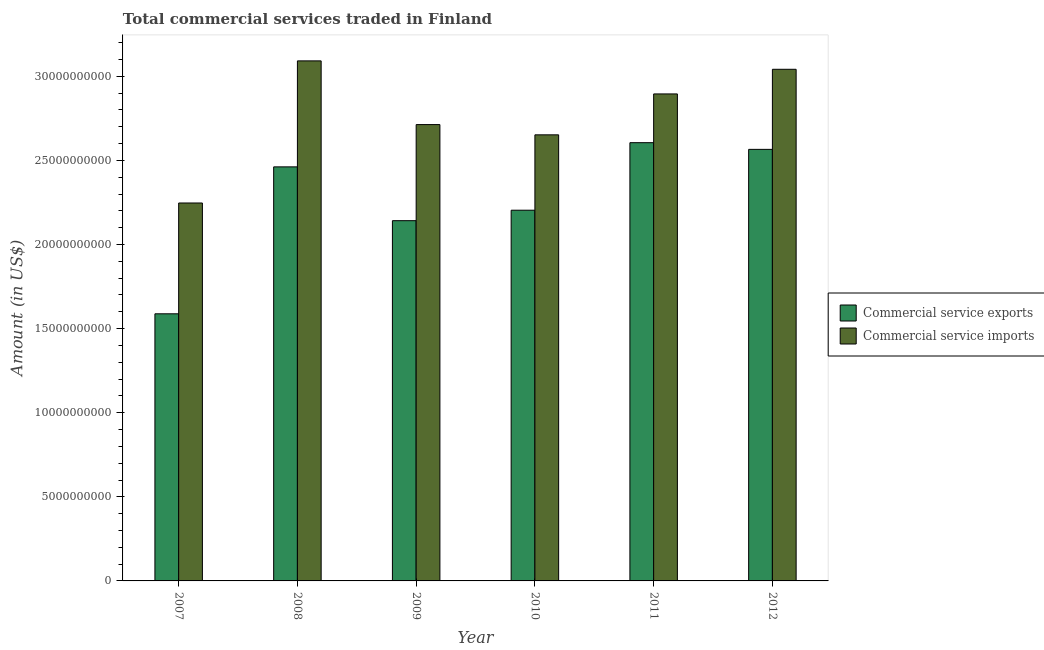How many bars are there on the 1st tick from the left?
Make the answer very short. 2. What is the label of the 4th group of bars from the left?
Provide a short and direct response. 2010. In how many cases, is the number of bars for a given year not equal to the number of legend labels?
Offer a very short reply. 0. What is the amount of commercial service exports in 2008?
Your answer should be compact. 2.46e+1. Across all years, what is the maximum amount of commercial service imports?
Offer a very short reply. 3.09e+1. Across all years, what is the minimum amount of commercial service exports?
Keep it short and to the point. 1.59e+1. In which year was the amount of commercial service imports maximum?
Your answer should be very brief. 2008. What is the total amount of commercial service imports in the graph?
Offer a very short reply. 1.66e+11. What is the difference between the amount of commercial service imports in 2008 and that in 2011?
Your answer should be very brief. 1.96e+09. What is the difference between the amount of commercial service imports in 2012 and the amount of commercial service exports in 2007?
Make the answer very short. 7.95e+09. What is the average amount of commercial service imports per year?
Keep it short and to the point. 2.77e+1. In how many years, is the amount of commercial service exports greater than 15000000000 US$?
Ensure brevity in your answer.  6. What is the ratio of the amount of commercial service exports in 2010 to that in 2012?
Give a very brief answer. 0.86. What is the difference between the highest and the second highest amount of commercial service imports?
Make the answer very short. 5.00e+08. What is the difference between the highest and the lowest amount of commercial service imports?
Offer a very short reply. 8.45e+09. Is the sum of the amount of commercial service imports in 2007 and 2012 greater than the maximum amount of commercial service exports across all years?
Offer a terse response. Yes. What does the 2nd bar from the left in 2007 represents?
Provide a short and direct response. Commercial service imports. What does the 2nd bar from the right in 2007 represents?
Ensure brevity in your answer.  Commercial service exports. Are all the bars in the graph horizontal?
Offer a very short reply. No. How many years are there in the graph?
Your answer should be very brief. 6. What is the difference between two consecutive major ticks on the Y-axis?
Offer a very short reply. 5.00e+09. What is the title of the graph?
Your answer should be compact. Total commercial services traded in Finland. What is the Amount (in US$) in Commercial service exports in 2007?
Provide a succinct answer. 1.59e+1. What is the Amount (in US$) of Commercial service imports in 2007?
Your response must be concise. 2.25e+1. What is the Amount (in US$) in Commercial service exports in 2008?
Your answer should be compact. 2.46e+1. What is the Amount (in US$) in Commercial service imports in 2008?
Your answer should be very brief. 3.09e+1. What is the Amount (in US$) in Commercial service exports in 2009?
Make the answer very short. 2.14e+1. What is the Amount (in US$) in Commercial service imports in 2009?
Give a very brief answer. 2.71e+1. What is the Amount (in US$) in Commercial service exports in 2010?
Your answer should be very brief. 2.20e+1. What is the Amount (in US$) in Commercial service imports in 2010?
Provide a succinct answer. 2.65e+1. What is the Amount (in US$) of Commercial service exports in 2011?
Keep it short and to the point. 2.61e+1. What is the Amount (in US$) of Commercial service imports in 2011?
Your response must be concise. 2.90e+1. What is the Amount (in US$) in Commercial service exports in 2012?
Provide a succinct answer. 2.57e+1. What is the Amount (in US$) of Commercial service imports in 2012?
Ensure brevity in your answer.  3.04e+1. Across all years, what is the maximum Amount (in US$) of Commercial service exports?
Keep it short and to the point. 2.61e+1. Across all years, what is the maximum Amount (in US$) in Commercial service imports?
Offer a very short reply. 3.09e+1. Across all years, what is the minimum Amount (in US$) in Commercial service exports?
Offer a very short reply. 1.59e+1. Across all years, what is the minimum Amount (in US$) of Commercial service imports?
Offer a terse response. 2.25e+1. What is the total Amount (in US$) of Commercial service exports in the graph?
Provide a succinct answer. 1.36e+11. What is the total Amount (in US$) in Commercial service imports in the graph?
Offer a terse response. 1.66e+11. What is the difference between the Amount (in US$) of Commercial service exports in 2007 and that in 2008?
Your answer should be compact. -8.74e+09. What is the difference between the Amount (in US$) in Commercial service imports in 2007 and that in 2008?
Make the answer very short. -8.45e+09. What is the difference between the Amount (in US$) of Commercial service exports in 2007 and that in 2009?
Make the answer very short. -5.54e+09. What is the difference between the Amount (in US$) of Commercial service imports in 2007 and that in 2009?
Your answer should be very brief. -4.66e+09. What is the difference between the Amount (in US$) in Commercial service exports in 2007 and that in 2010?
Give a very brief answer. -6.16e+09. What is the difference between the Amount (in US$) in Commercial service imports in 2007 and that in 2010?
Your answer should be compact. -4.05e+09. What is the difference between the Amount (in US$) in Commercial service exports in 2007 and that in 2011?
Provide a succinct answer. -1.02e+1. What is the difference between the Amount (in US$) in Commercial service imports in 2007 and that in 2011?
Your response must be concise. -6.48e+09. What is the difference between the Amount (in US$) in Commercial service exports in 2007 and that in 2012?
Offer a terse response. -9.78e+09. What is the difference between the Amount (in US$) in Commercial service imports in 2007 and that in 2012?
Ensure brevity in your answer.  -7.95e+09. What is the difference between the Amount (in US$) in Commercial service exports in 2008 and that in 2009?
Provide a short and direct response. 3.20e+09. What is the difference between the Amount (in US$) in Commercial service imports in 2008 and that in 2009?
Make the answer very short. 3.79e+09. What is the difference between the Amount (in US$) in Commercial service exports in 2008 and that in 2010?
Give a very brief answer. 2.58e+09. What is the difference between the Amount (in US$) in Commercial service imports in 2008 and that in 2010?
Ensure brevity in your answer.  4.40e+09. What is the difference between the Amount (in US$) in Commercial service exports in 2008 and that in 2011?
Offer a terse response. -1.44e+09. What is the difference between the Amount (in US$) in Commercial service imports in 2008 and that in 2011?
Provide a succinct answer. 1.96e+09. What is the difference between the Amount (in US$) of Commercial service exports in 2008 and that in 2012?
Keep it short and to the point. -1.04e+09. What is the difference between the Amount (in US$) in Commercial service imports in 2008 and that in 2012?
Your answer should be compact. 5.00e+08. What is the difference between the Amount (in US$) in Commercial service exports in 2009 and that in 2010?
Offer a very short reply. -6.22e+08. What is the difference between the Amount (in US$) in Commercial service imports in 2009 and that in 2010?
Provide a short and direct response. 6.09e+08. What is the difference between the Amount (in US$) of Commercial service exports in 2009 and that in 2011?
Give a very brief answer. -4.64e+09. What is the difference between the Amount (in US$) of Commercial service imports in 2009 and that in 2011?
Your answer should be very brief. -1.82e+09. What is the difference between the Amount (in US$) in Commercial service exports in 2009 and that in 2012?
Make the answer very short. -4.24e+09. What is the difference between the Amount (in US$) in Commercial service imports in 2009 and that in 2012?
Your response must be concise. -3.29e+09. What is the difference between the Amount (in US$) in Commercial service exports in 2010 and that in 2011?
Your answer should be very brief. -4.02e+09. What is the difference between the Amount (in US$) in Commercial service imports in 2010 and that in 2011?
Make the answer very short. -2.43e+09. What is the difference between the Amount (in US$) in Commercial service exports in 2010 and that in 2012?
Your response must be concise. -3.62e+09. What is the difference between the Amount (in US$) of Commercial service imports in 2010 and that in 2012?
Provide a short and direct response. -3.90e+09. What is the difference between the Amount (in US$) of Commercial service exports in 2011 and that in 2012?
Your answer should be compact. 3.98e+08. What is the difference between the Amount (in US$) of Commercial service imports in 2011 and that in 2012?
Your answer should be very brief. -1.46e+09. What is the difference between the Amount (in US$) in Commercial service exports in 2007 and the Amount (in US$) in Commercial service imports in 2008?
Give a very brief answer. -1.50e+1. What is the difference between the Amount (in US$) in Commercial service exports in 2007 and the Amount (in US$) in Commercial service imports in 2009?
Your answer should be very brief. -1.13e+1. What is the difference between the Amount (in US$) of Commercial service exports in 2007 and the Amount (in US$) of Commercial service imports in 2010?
Provide a short and direct response. -1.06e+1. What is the difference between the Amount (in US$) in Commercial service exports in 2007 and the Amount (in US$) in Commercial service imports in 2011?
Keep it short and to the point. -1.31e+1. What is the difference between the Amount (in US$) in Commercial service exports in 2007 and the Amount (in US$) in Commercial service imports in 2012?
Your answer should be very brief. -1.45e+1. What is the difference between the Amount (in US$) in Commercial service exports in 2008 and the Amount (in US$) in Commercial service imports in 2009?
Give a very brief answer. -2.51e+09. What is the difference between the Amount (in US$) of Commercial service exports in 2008 and the Amount (in US$) of Commercial service imports in 2010?
Make the answer very short. -1.90e+09. What is the difference between the Amount (in US$) of Commercial service exports in 2008 and the Amount (in US$) of Commercial service imports in 2011?
Provide a succinct answer. -4.34e+09. What is the difference between the Amount (in US$) of Commercial service exports in 2008 and the Amount (in US$) of Commercial service imports in 2012?
Ensure brevity in your answer.  -5.80e+09. What is the difference between the Amount (in US$) of Commercial service exports in 2009 and the Amount (in US$) of Commercial service imports in 2010?
Offer a terse response. -5.10e+09. What is the difference between the Amount (in US$) of Commercial service exports in 2009 and the Amount (in US$) of Commercial service imports in 2011?
Your answer should be very brief. -7.54e+09. What is the difference between the Amount (in US$) in Commercial service exports in 2009 and the Amount (in US$) in Commercial service imports in 2012?
Offer a very short reply. -9.00e+09. What is the difference between the Amount (in US$) in Commercial service exports in 2010 and the Amount (in US$) in Commercial service imports in 2011?
Make the answer very short. -6.91e+09. What is the difference between the Amount (in US$) of Commercial service exports in 2010 and the Amount (in US$) of Commercial service imports in 2012?
Keep it short and to the point. -8.38e+09. What is the difference between the Amount (in US$) of Commercial service exports in 2011 and the Amount (in US$) of Commercial service imports in 2012?
Keep it short and to the point. -4.36e+09. What is the average Amount (in US$) in Commercial service exports per year?
Your response must be concise. 2.26e+1. What is the average Amount (in US$) of Commercial service imports per year?
Make the answer very short. 2.77e+1. In the year 2007, what is the difference between the Amount (in US$) in Commercial service exports and Amount (in US$) in Commercial service imports?
Make the answer very short. -6.59e+09. In the year 2008, what is the difference between the Amount (in US$) of Commercial service exports and Amount (in US$) of Commercial service imports?
Provide a short and direct response. -6.30e+09. In the year 2009, what is the difference between the Amount (in US$) of Commercial service exports and Amount (in US$) of Commercial service imports?
Give a very brief answer. -5.71e+09. In the year 2010, what is the difference between the Amount (in US$) in Commercial service exports and Amount (in US$) in Commercial service imports?
Ensure brevity in your answer.  -4.48e+09. In the year 2011, what is the difference between the Amount (in US$) in Commercial service exports and Amount (in US$) in Commercial service imports?
Make the answer very short. -2.90e+09. In the year 2012, what is the difference between the Amount (in US$) of Commercial service exports and Amount (in US$) of Commercial service imports?
Provide a succinct answer. -4.76e+09. What is the ratio of the Amount (in US$) of Commercial service exports in 2007 to that in 2008?
Your response must be concise. 0.65. What is the ratio of the Amount (in US$) in Commercial service imports in 2007 to that in 2008?
Ensure brevity in your answer.  0.73. What is the ratio of the Amount (in US$) in Commercial service exports in 2007 to that in 2009?
Your answer should be very brief. 0.74. What is the ratio of the Amount (in US$) in Commercial service imports in 2007 to that in 2009?
Your answer should be compact. 0.83. What is the ratio of the Amount (in US$) in Commercial service exports in 2007 to that in 2010?
Offer a terse response. 0.72. What is the ratio of the Amount (in US$) in Commercial service imports in 2007 to that in 2010?
Your response must be concise. 0.85. What is the ratio of the Amount (in US$) of Commercial service exports in 2007 to that in 2011?
Make the answer very short. 0.61. What is the ratio of the Amount (in US$) of Commercial service imports in 2007 to that in 2011?
Offer a very short reply. 0.78. What is the ratio of the Amount (in US$) in Commercial service exports in 2007 to that in 2012?
Keep it short and to the point. 0.62. What is the ratio of the Amount (in US$) in Commercial service imports in 2007 to that in 2012?
Make the answer very short. 0.74. What is the ratio of the Amount (in US$) in Commercial service exports in 2008 to that in 2009?
Your answer should be very brief. 1.15. What is the ratio of the Amount (in US$) of Commercial service imports in 2008 to that in 2009?
Offer a very short reply. 1.14. What is the ratio of the Amount (in US$) in Commercial service exports in 2008 to that in 2010?
Keep it short and to the point. 1.12. What is the ratio of the Amount (in US$) of Commercial service imports in 2008 to that in 2010?
Keep it short and to the point. 1.17. What is the ratio of the Amount (in US$) of Commercial service exports in 2008 to that in 2011?
Ensure brevity in your answer.  0.94. What is the ratio of the Amount (in US$) of Commercial service imports in 2008 to that in 2011?
Provide a short and direct response. 1.07. What is the ratio of the Amount (in US$) in Commercial service exports in 2008 to that in 2012?
Give a very brief answer. 0.96. What is the ratio of the Amount (in US$) of Commercial service imports in 2008 to that in 2012?
Provide a succinct answer. 1.02. What is the ratio of the Amount (in US$) in Commercial service exports in 2009 to that in 2010?
Keep it short and to the point. 0.97. What is the ratio of the Amount (in US$) of Commercial service exports in 2009 to that in 2011?
Make the answer very short. 0.82. What is the ratio of the Amount (in US$) in Commercial service imports in 2009 to that in 2011?
Your response must be concise. 0.94. What is the ratio of the Amount (in US$) of Commercial service exports in 2009 to that in 2012?
Offer a very short reply. 0.83. What is the ratio of the Amount (in US$) of Commercial service imports in 2009 to that in 2012?
Your answer should be compact. 0.89. What is the ratio of the Amount (in US$) of Commercial service exports in 2010 to that in 2011?
Provide a short and direct response. 0.85. What is the ratio of the Amount (in US$) in Commercial service imports in 2010 to that in 2011?
Your response must be concise. 0.92. What is the ratio of the Amount (in US$) of Commercial service exports in 2010 to that in 2012?
Offer a very short reply. 0.86. What is the ratio of the Amount (in US$) in Commercial service imports in 2010 to that in 2012?
Ensure brevity in your answer.  0.87. What is the ratio of the Amount (in US$) in Commercial service exports in 2011 to that in 2012?
Offer a terse response. 1.02. What is the ratio of the Amount (in US$) of Commercial service imports in 2011 to that in 2012?
Give a very brief answer. 0.95. What is the difference between the highest and the second highest Amount (in US$) of Commercial service exports?
Ensure brevity in your answer.  3.98e+08. What is the difference between the highest and the second highest Amount (in US$) of Commercial service imports?
Offer a terse response. 5.00e+08. What is the difference between the highest and the lowest Amount (in US$) in Commercial service exports?
Provide a short and direct response. 1.02e+1. What is the difference between the highest and the lowest Amount (in US$) of Commercial service imports?
Make the answer very short. 8.45e+09. 